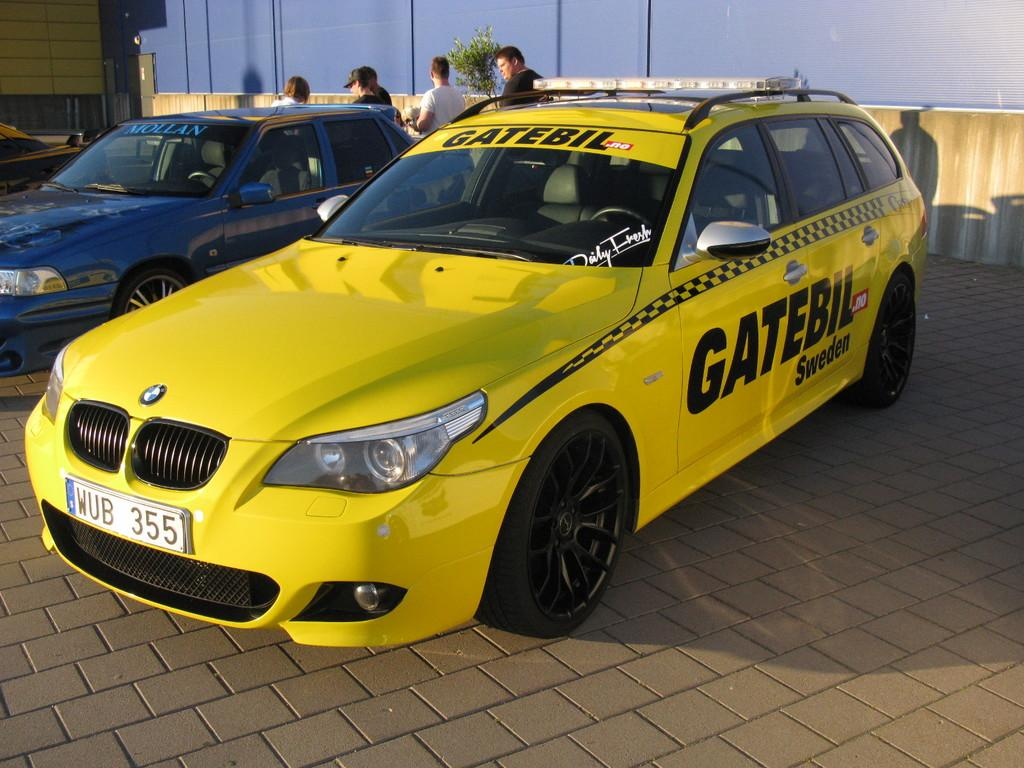Provide a one-sentence caption for the provided image. a Gate car that is yellow in color. 